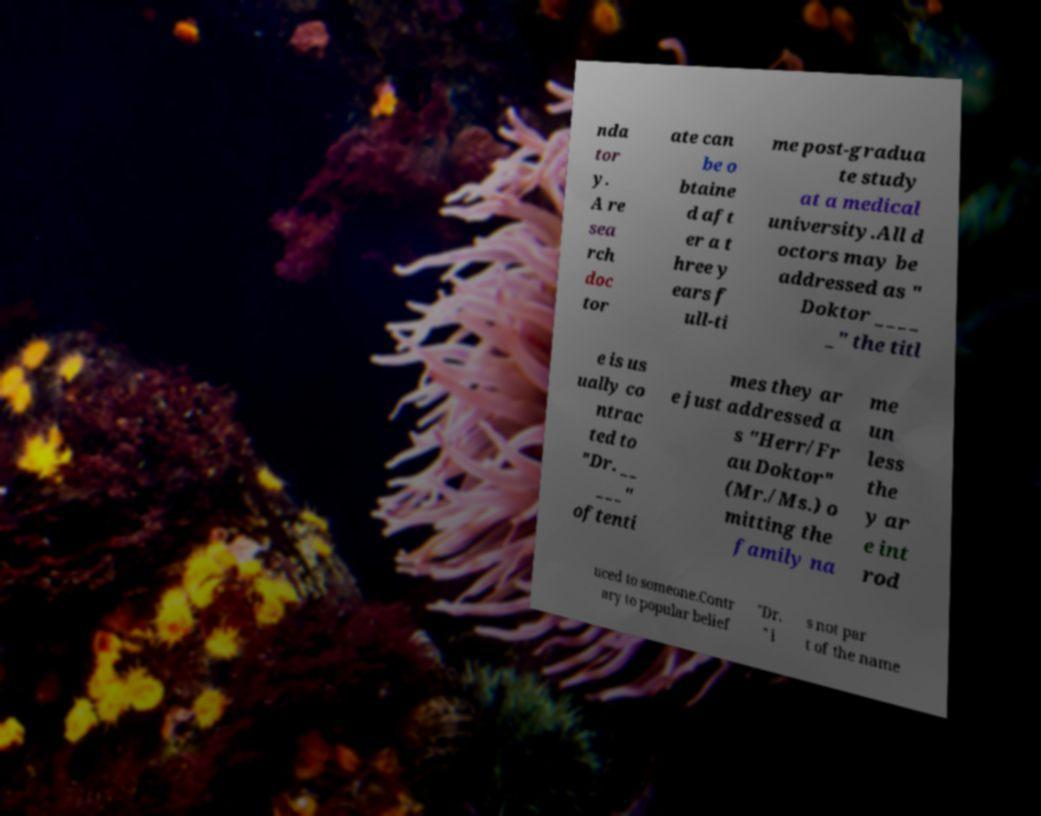Can you accurately transcribe the text from the provided image for me? nda tor y. A re sea rch doc tor ate can be o btaine d aft er a t hree y ears f ull-ti me post-gradua te study at a medical university.All d octors may be addressed as " Doktor ____ _" the titl e is us ually co ntrac ted to "Dr. __ ___" oftenti mes they ar e just addressed a s "Herr/Fr au Doktor" (Mr./Ms.) o mitting the family na me un less the y ar e int rod uced to someone.Contr ary to popular belief "Dr. " i s not par t of the name 